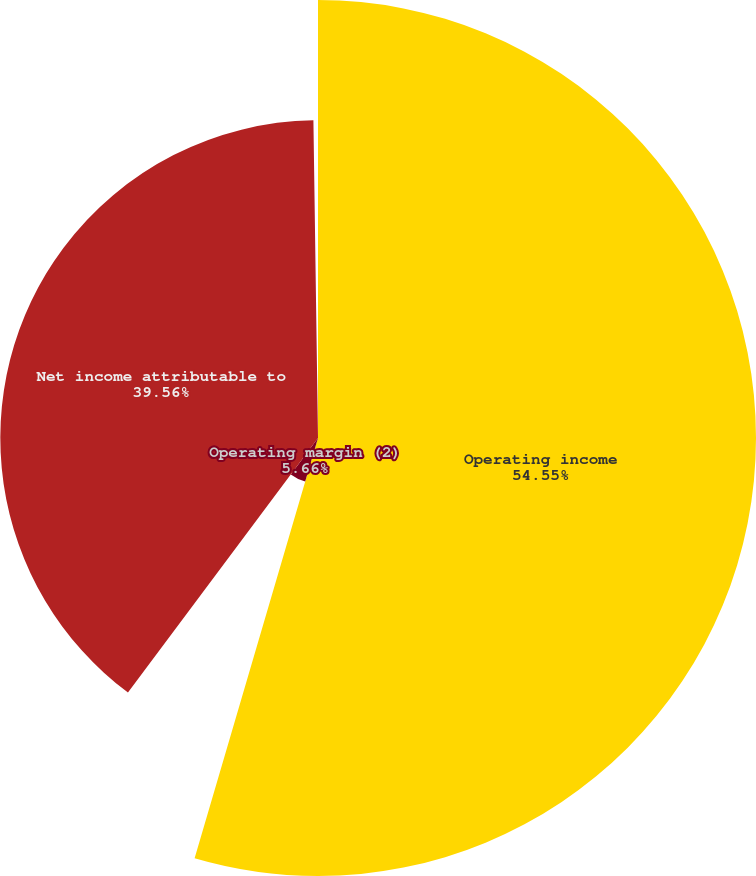<chart> <loc_0><loc_0><loc_500><loc_500><pie_chart><fcel>Operating income<fcel>Operating margin (2)<fcel>Net income attributable to<fcel>Diluted earnings per common<nl><fcel>54.54%<fcel>5.66%<fcel>39.56%<fcel>0.23%<nl></chart> 